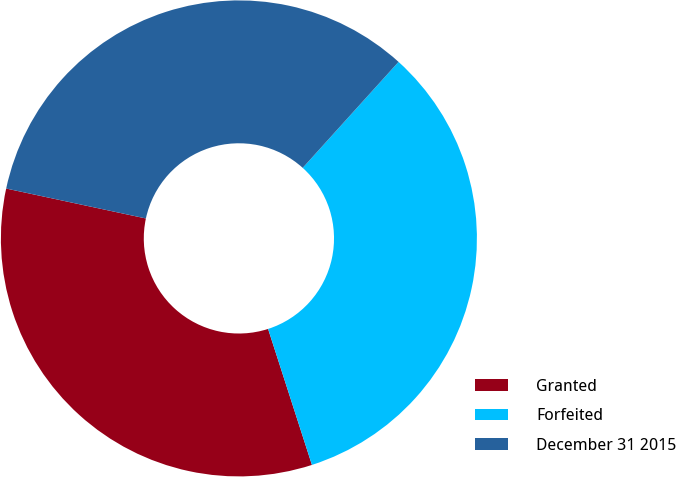Convert chart to OTSL. <chart><loc_0><loc_0><loc_500><loc_500><pie_chart><fcel>Granted<fcel>Forfeited<fcel>December 31 2015<nl><fcel>33.32%<fcel>33.33%<fcel>33.34%<nl></chart> 